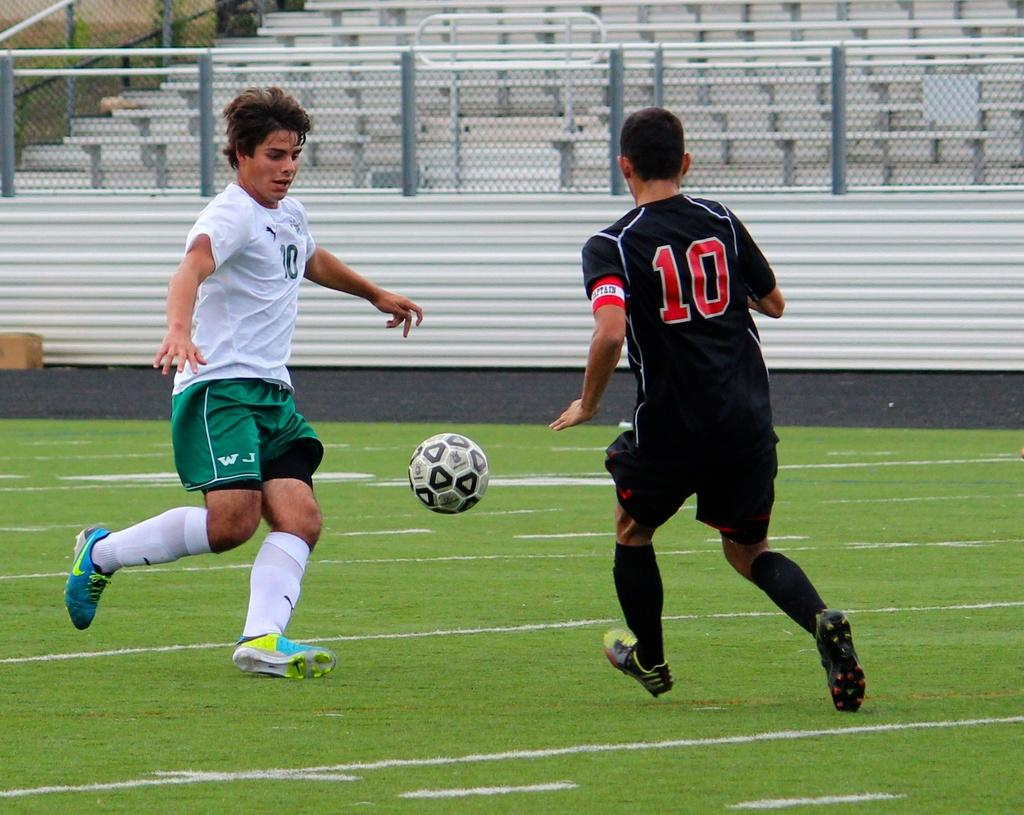<image>
Summarize the visual content of the image. two men playing soccer one in a white shirt one in a black shirt with a red 10 on the back. 